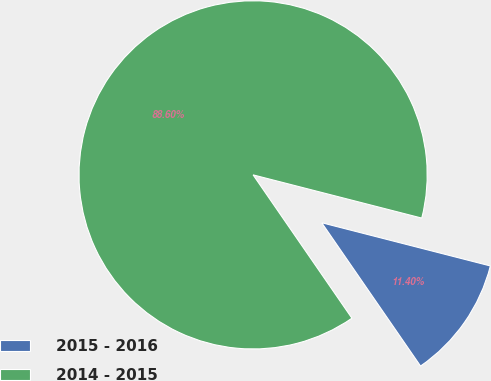<chart> <loc_0><loc_0><loc_500><loc_500><pie_chart><fcel>2015 - 2016<fcel>2014 - 2015<nl><fcel>11.4%<fcel>88.6%<nl></chart> 